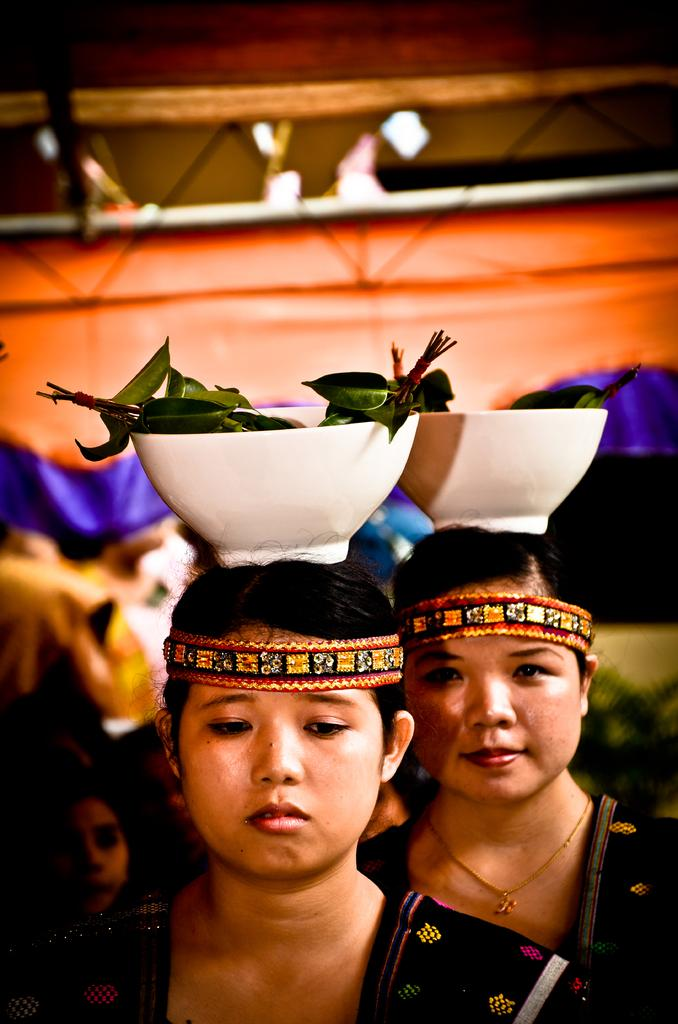What are the people at the bottom of the image doing? There are people standing at the bottom of the image. What are two of the people holding on their heads? Two persons are holding bowls on their heads. What is inside the bowls? The bowls contain leaves. What structure can be seen at the top of the image? There is a tent at the top of the image. What book is the person reading in the image? There is no person reading a book in the image. What type of drug can be seen in the image? There is no drug present in the image. 